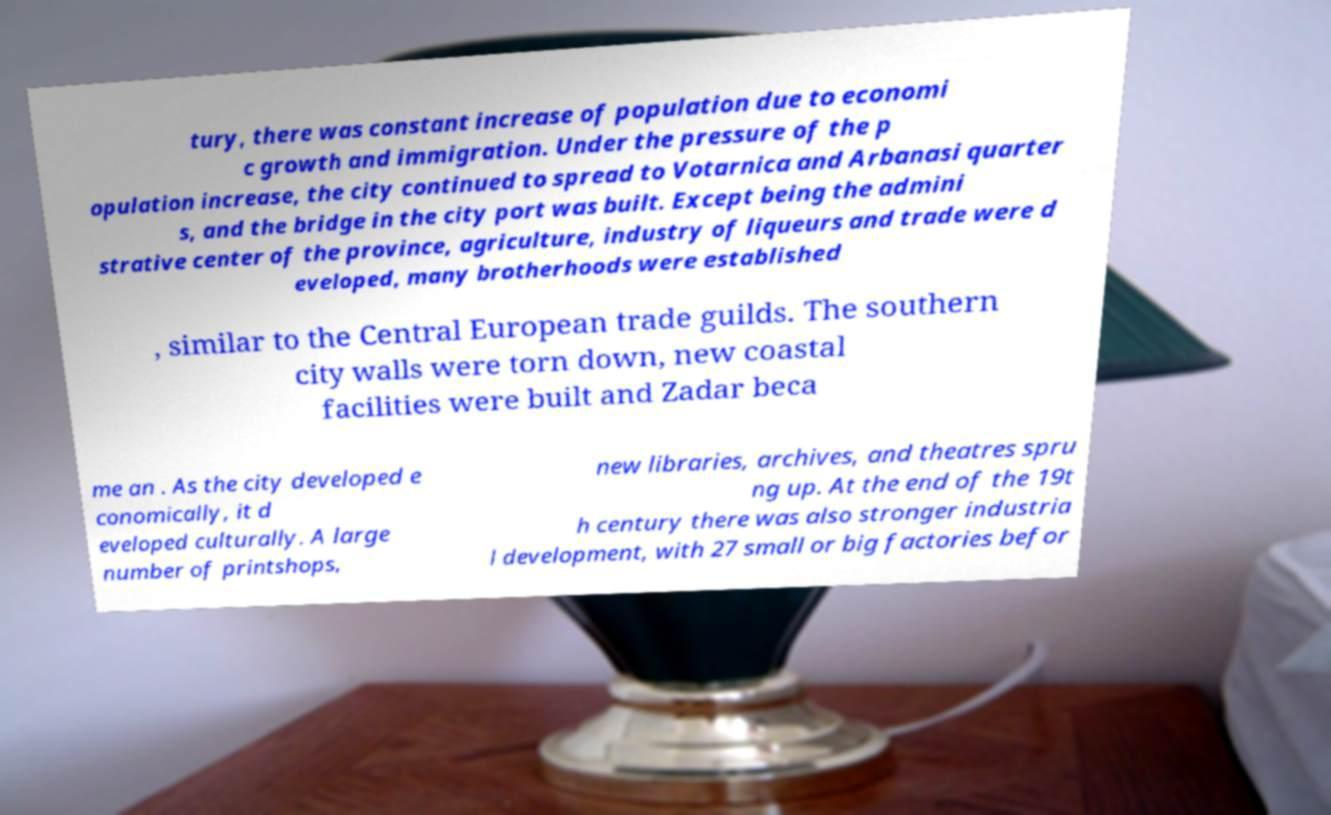Please read and relay the text visible in this image. What does it say? tury, there was constant increase of population due to economi c growth and immigration. Under the pressure of the p opulation increase, the city continued to spread to Votarnica and Arbanasi quarter s, and the bridge in the city port was built. Except being the admini strative center of the province, agriculture, industry of liqueurs and trade were d eveloped, many brotherhoods were established , similar to the Central European trade guilds. The southern city walls were torn down, new coastal facilities were built and Zadar beca me an . As the city developed e conomically, it d eveloped culturally. A large number of printshops, new libraries, archives, and theatres spru ng up. At the end of the 19t h century there was also stronger industria l development, with 27 small or big factories befor 